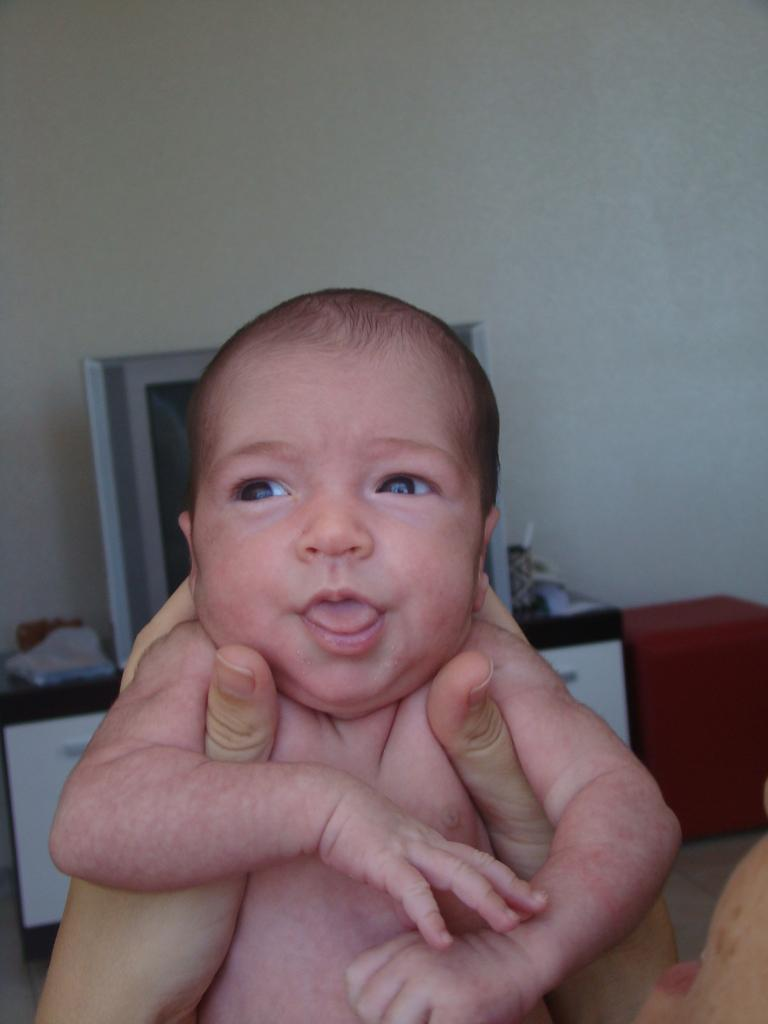What is the person in the image doing? The person is holding a baby in the image. What can be seen in the background of the image? There is a wall and objects visible in the background of the image. What type of liquid is being poured by the scarecrow in the image? There is no scarecrow or liquid present in the image. How many balls are visible in the image? There are no balls visible in the image. 